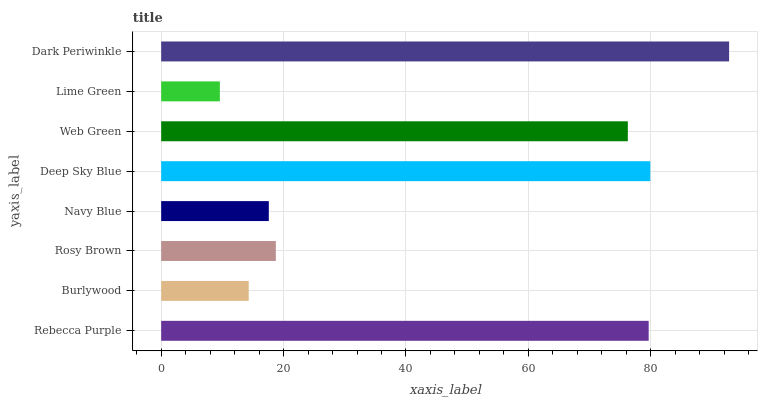Is Lime Green the minimum?
Answer yes or no. Yes. Is Dark Periwinkle the maximum?
Answer yes or no. Yes. Is Burlywood the minimum?
Answer yes or no. No. Is Burlywood the maximum?
Answer yes or no. No. Is Rebecca Purple greater than Burlywood?
Answer yes or no. Yes. Is Burlywood less than Rebecca Purple?
Answer yes or no. Yes. Is Burlywood greater than Rebecca Purple?
Answer yes or no. No. Is Rebecca Purple less than Burlywood?
Answer yes or no. No. Is Web Green the high median?
Answer yes or no. Yes. Is Rosy Brown the low median?
Answer yes or no. Yes. Is Dark Periwinkle the high median?
Answer yes or no. No. Is Dark Periwinkle the low median?
Answer yes or no. No. 